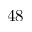<formula> <loc_0><loc_0><loc_500><loc_500>4 8</formula> 